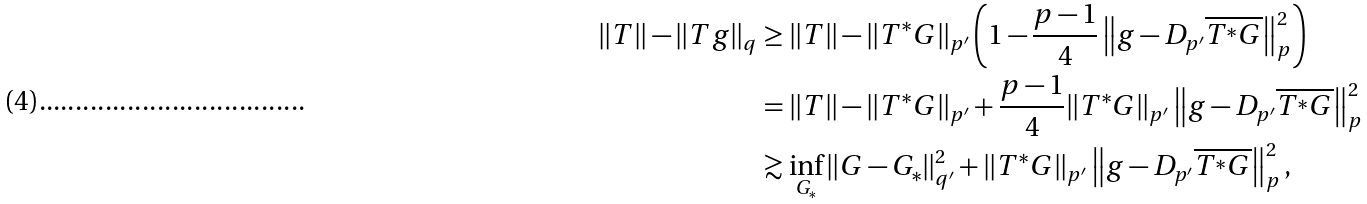<formula> <loc_0><loc_0><loc_500><loc_500>\| T \| - \| T g \| _ { q } & \geq \| T \| - \| T ^ { \ast } G \| _ { p ^ { \prime } } \left ( 1 - \frac { p - 1 } { 4 } \left \| g - D _ { p ^ { \prime } } \overline { T ^ { \ast } G } \right \| _ { p } ^ { 2 } \right ) \\ & = \| T \| - \| T ^ { \ast } G \| _ { p ^ { \prime } } + \frac { p - 1 } { 4 } \| T ^ { \ast } G \| _ { p ^ { \prime } } \left \| g - D _ { p ^ { \prime } } \overline { T ^ { \ast } G } \right \| _ { p } ^ { 2 } \\ & \gtrsim \inf _ { G _ { \ast } } \| G - G _ { \ast } \| _ { q ^ { \prime } } ^ { 2 } + \| T ^ { \ast } G \| _ { p ^ { \prime } } \left \| g - D _ { p ^ { \prime } } \overline { T ^ { \ast } G } \right \| _ { p } ^ { 2 } ,</formula> 